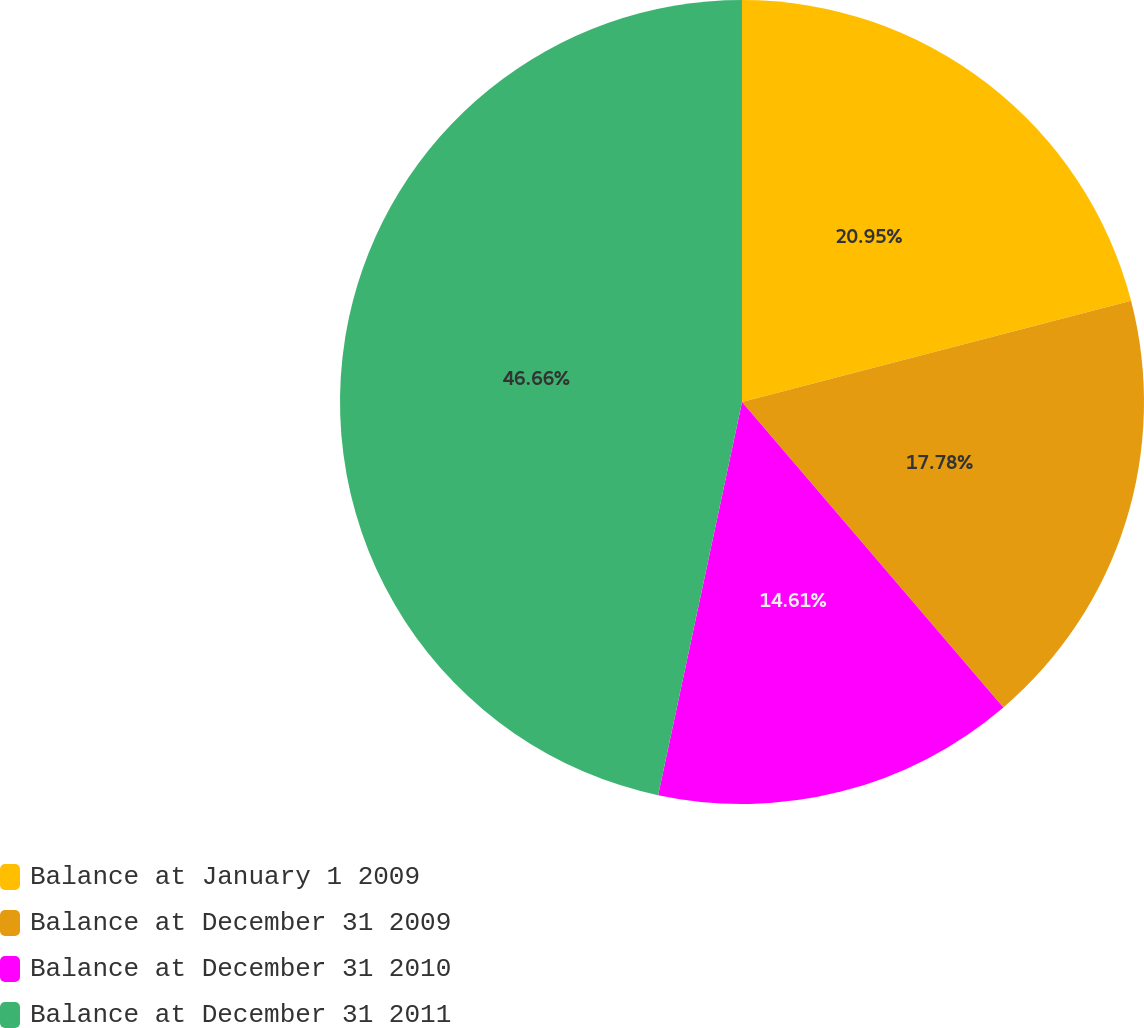<chart> <loc_0><loc_0><loc_500><loc_500><pie_chart><fcel>Balance at January 1 2009<fcel>Balance at December 31 2009<fcel>Balance at December 31 2010<fcel>Balance at December 31 2011<nl><fcel>20.95%<fcel>17.78%<fcel>14.61%<fcel>46.65%<nl></chart> 